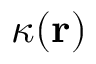<formula> <loc_0><loc_0><loc_500><loc_500>\kappa ( r )</formula> 